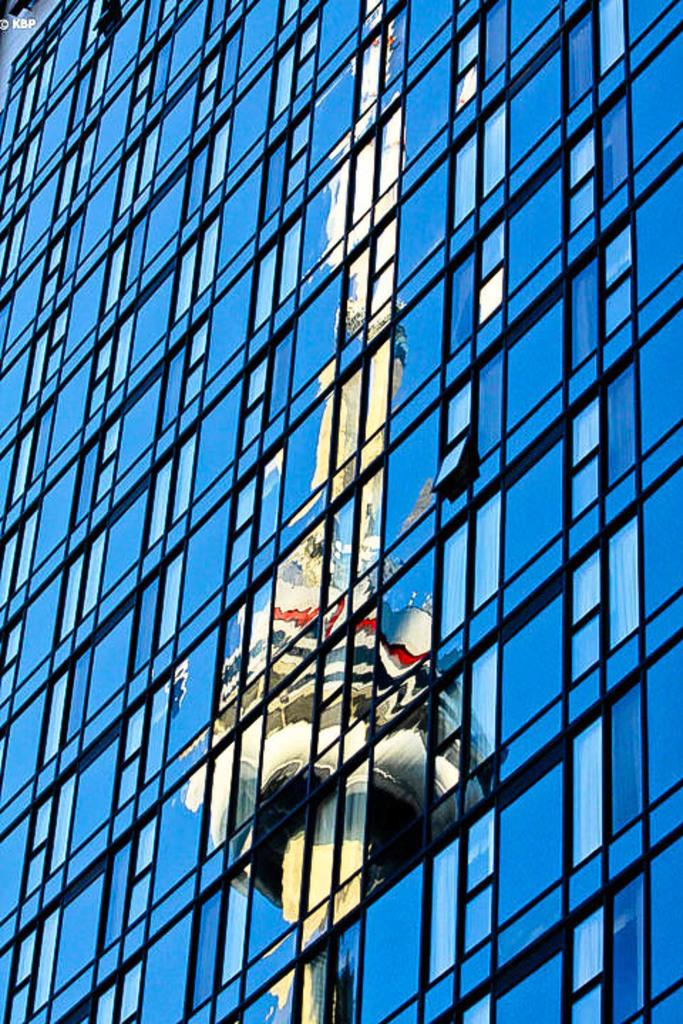What type of building is depicted in the image? There is a glass building in the image. What can be seen reflected on the glass building? The glass building has a reflection of a tower. Can you see an owl perched on the glass building in the image? No, there is no owl present in the image. Is there a water source visible in the image? No, there is no water source visible in the image. 